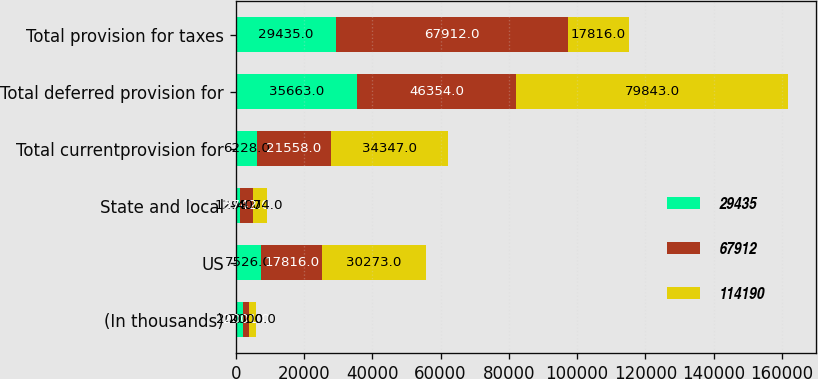<chart> <loc_0><loc_0><loc_500><loc_500><stacked_bar_chart><ecel><fcel>(In thousands)<fcel>US<fcel>State and local<fcel>Total currentprovision for<fcel>Total deferred provision for<fcel>Total provision for taxes<nl><fcel>29435<fcel>2002<fcel>7526<fcel>1298<fcel>6228<fcel>35663<fcel>29435<nl><fcel>67912<fcel>2001<fcel>17816<fcel>3742<fcel>21558<fcel>46354<fcel>67912<nl><fcel>114190<fcel>2000<fcel>30273<fcel>4074<fcel>34347<fcel>79843<fcel>17816<nl></chart> 